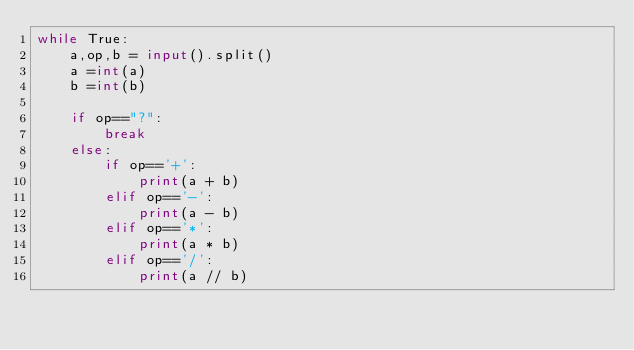<code> <loc_0><loc_0><loc_500><loc_500><_Python_>while True:
    a,op,b = input().split()     
    a =int(a)                   
    b =int(b)                   

    if op=="?": 
        break
    else:    
        if op=='+':
            print(a + b)
        elif op=='-':
            print(a - b)
        elif op=='*':
            print(a * b)
        elif op=='/':
            print(a // b)
</code> 